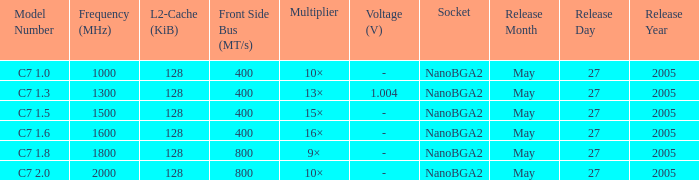What is the Frequency for Model Number c7 1.0? 1000 MHz. 